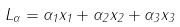<formula> <loc_0><loc_0><loc_500><loc_500>L _ { \alpha } = \alpha _ { 1 } x _ { 1 } + \alpha _ { 2 } x _ { 2 } + \alpha _ { 3 } x _ { 3 }</formula> 